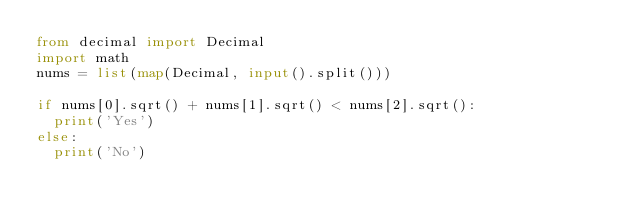Convert code to text. <code><loc_0><loc_0><loc_500><loc_500><_Python_>from decimal import Decimal
import math
nums = list(map(Decimal, input().split()))

if nums[0].sqrt() + nums[1].sqrt() < nums[2].sqrt():
  print('Yes')
else:
  print('No')
</code> 